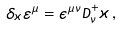<formula> <loc_0><loc_0><loc_500><loc_500>\delta _ { \varkappa } \varepsilon ^ { \mu } = \epsilon ^ { \mu \nu } { D } ^ { + } _ { \nu } \varkappa \, ,</formula> 